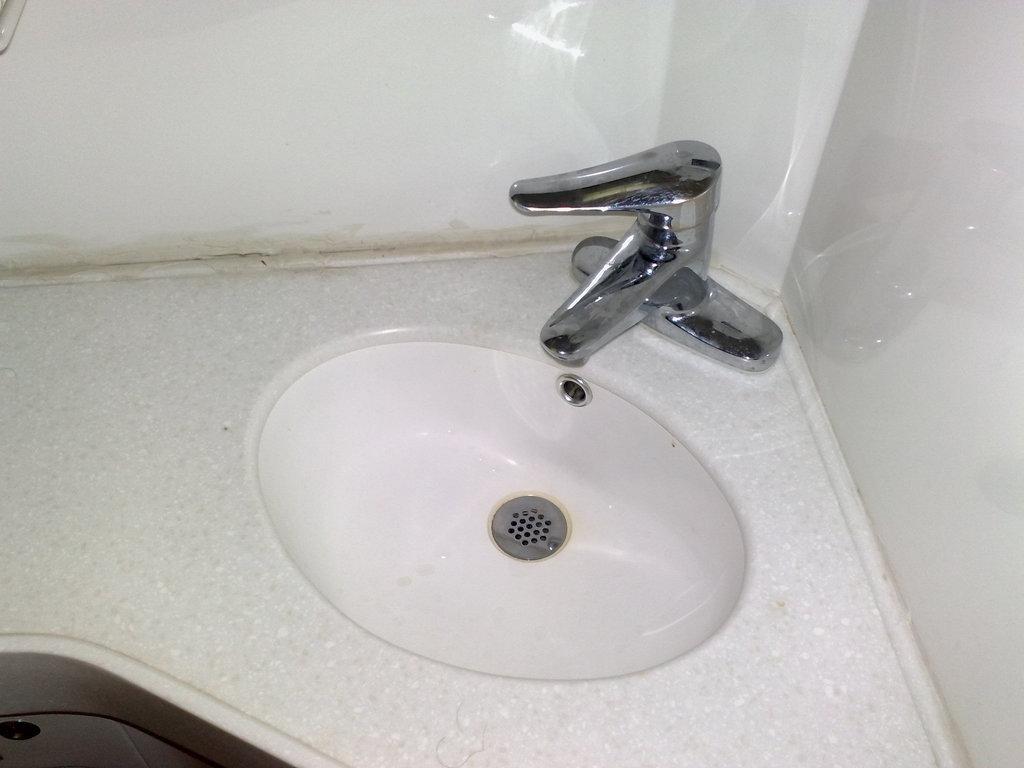Please provide a concise description of this image. In this image, we can see a wash basin and a tap, we can see the walls. 